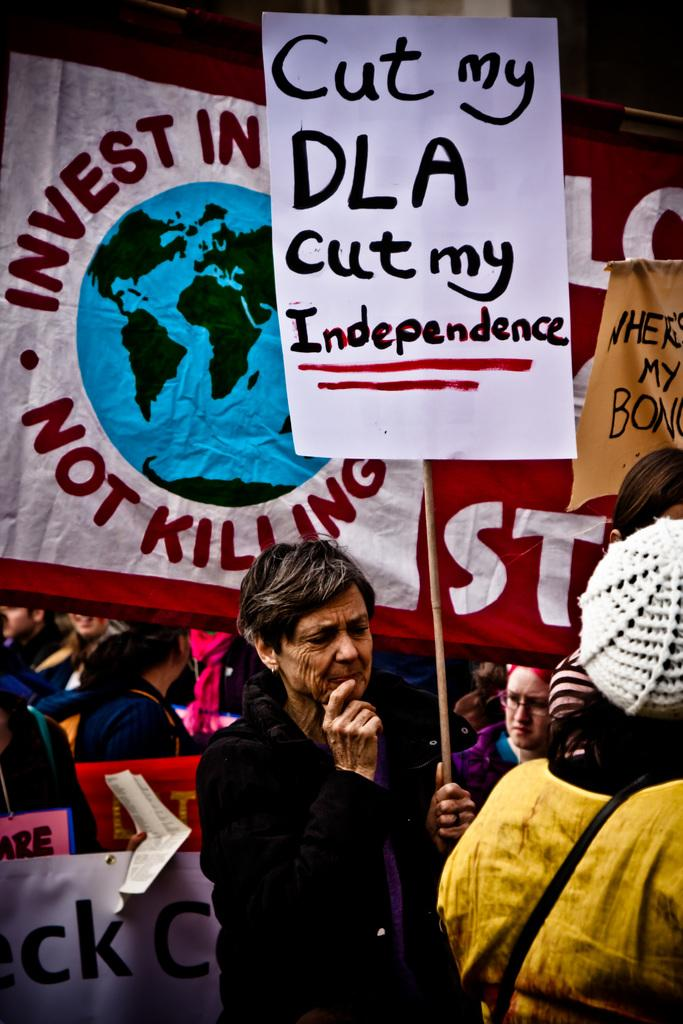Who is present in the image? There is a woman in the image. What is the woman holding in the image? The woman is holding a stick. What is written on the stick? The writing on the stick says "cut my DLA cut My independence." Can you see a stream of water in the image? There is no stream of water present in the image. Is there any glue visible on the stick? There is no glue visible on the stick in the image. 